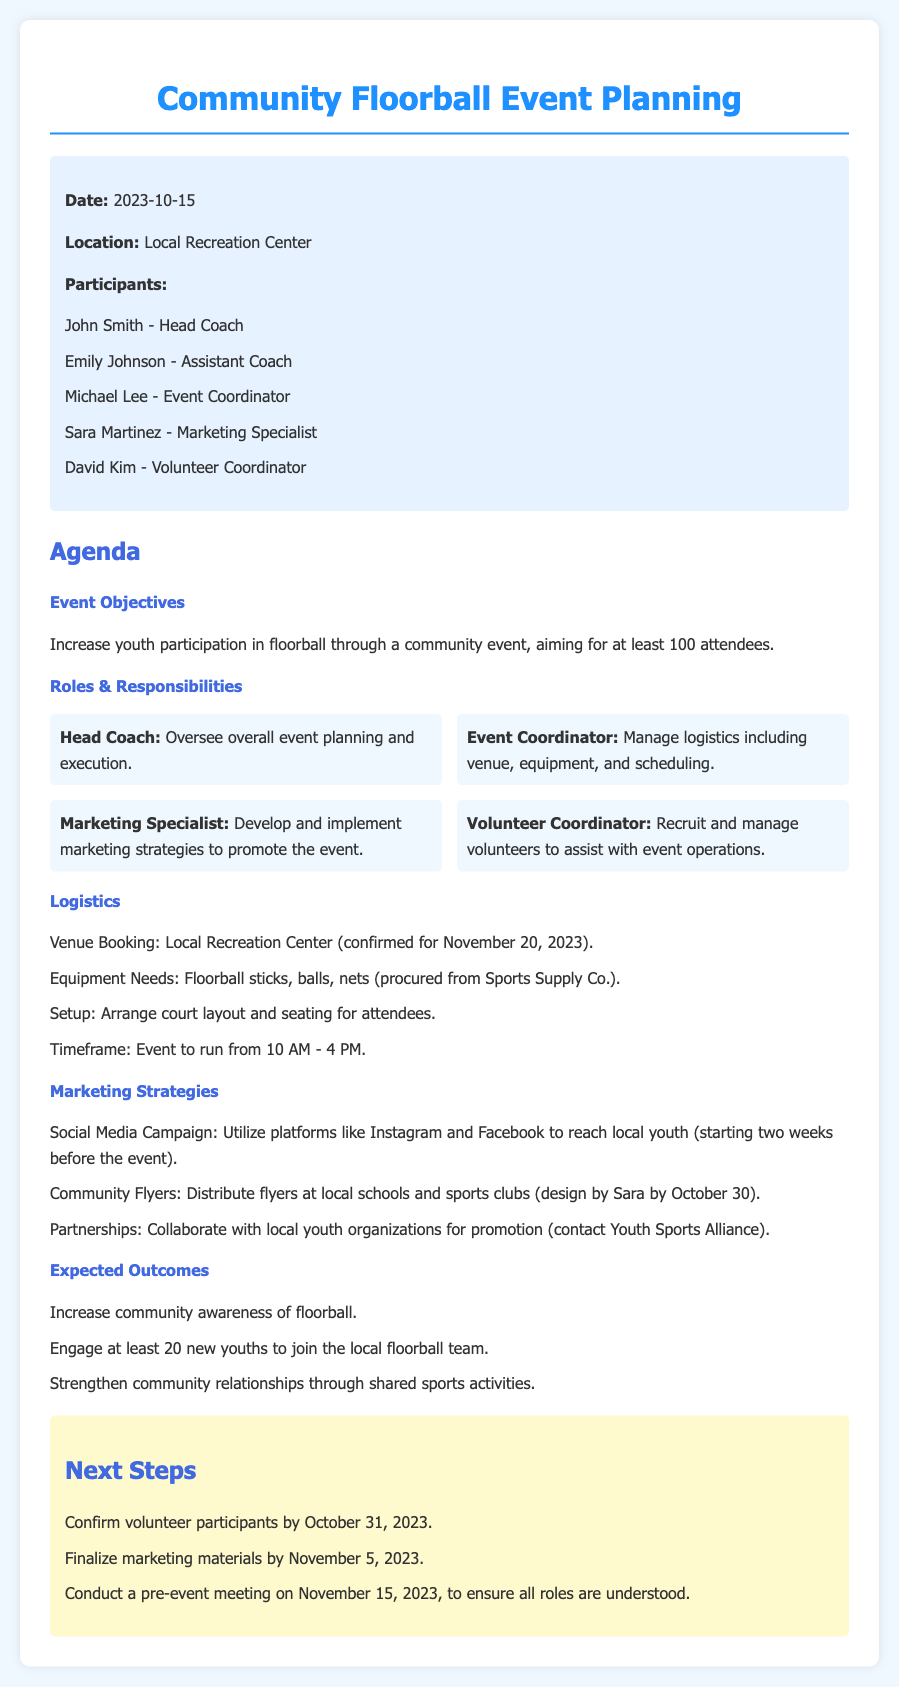What is the date of the event? The event is scheduled for November 20, 2023, as mentioned in the logistics section.
Answer: November 20, 2023 Who is the Marketing Specialist? The Marketing Specialist responsible for promoting the event is listed in the participants section.
Answer: Sara Martinez What are the expected outcomes of the event? The expected outcomes are outlined in the corresponding section, listing three key results.
Answer: Increase community awareness of floorball, engage at least 20 new youths to join the local floorball team, strengthen community relationships through shared sports activities How long is the event planned to run? The timeframe for the event is specified in the logistics section, indicating the hours of operation.
Answer: 10 AM - 4 PM When is the pre-event meeting scheduled? The date for the pre-event meeting is detailed in the next steps section of the document.
Answer: November 15, 2023 What will the Marketing Specialist be designing by October 30? The document specifies that the Marketing Specialist will design materials to promote the event, particularly flyers.
Answer: Flyers What is the aim for the number of attendees at the event? The document states the objective clearly, which reflects the goal set for the event attendance.
Answer: At least 100 attendees Who is responsible for managing logistics? The event coordinator's role for overseeing logistics and decision-making is outlined in the roles and responsibilities section.
Answer: Michael Lee 